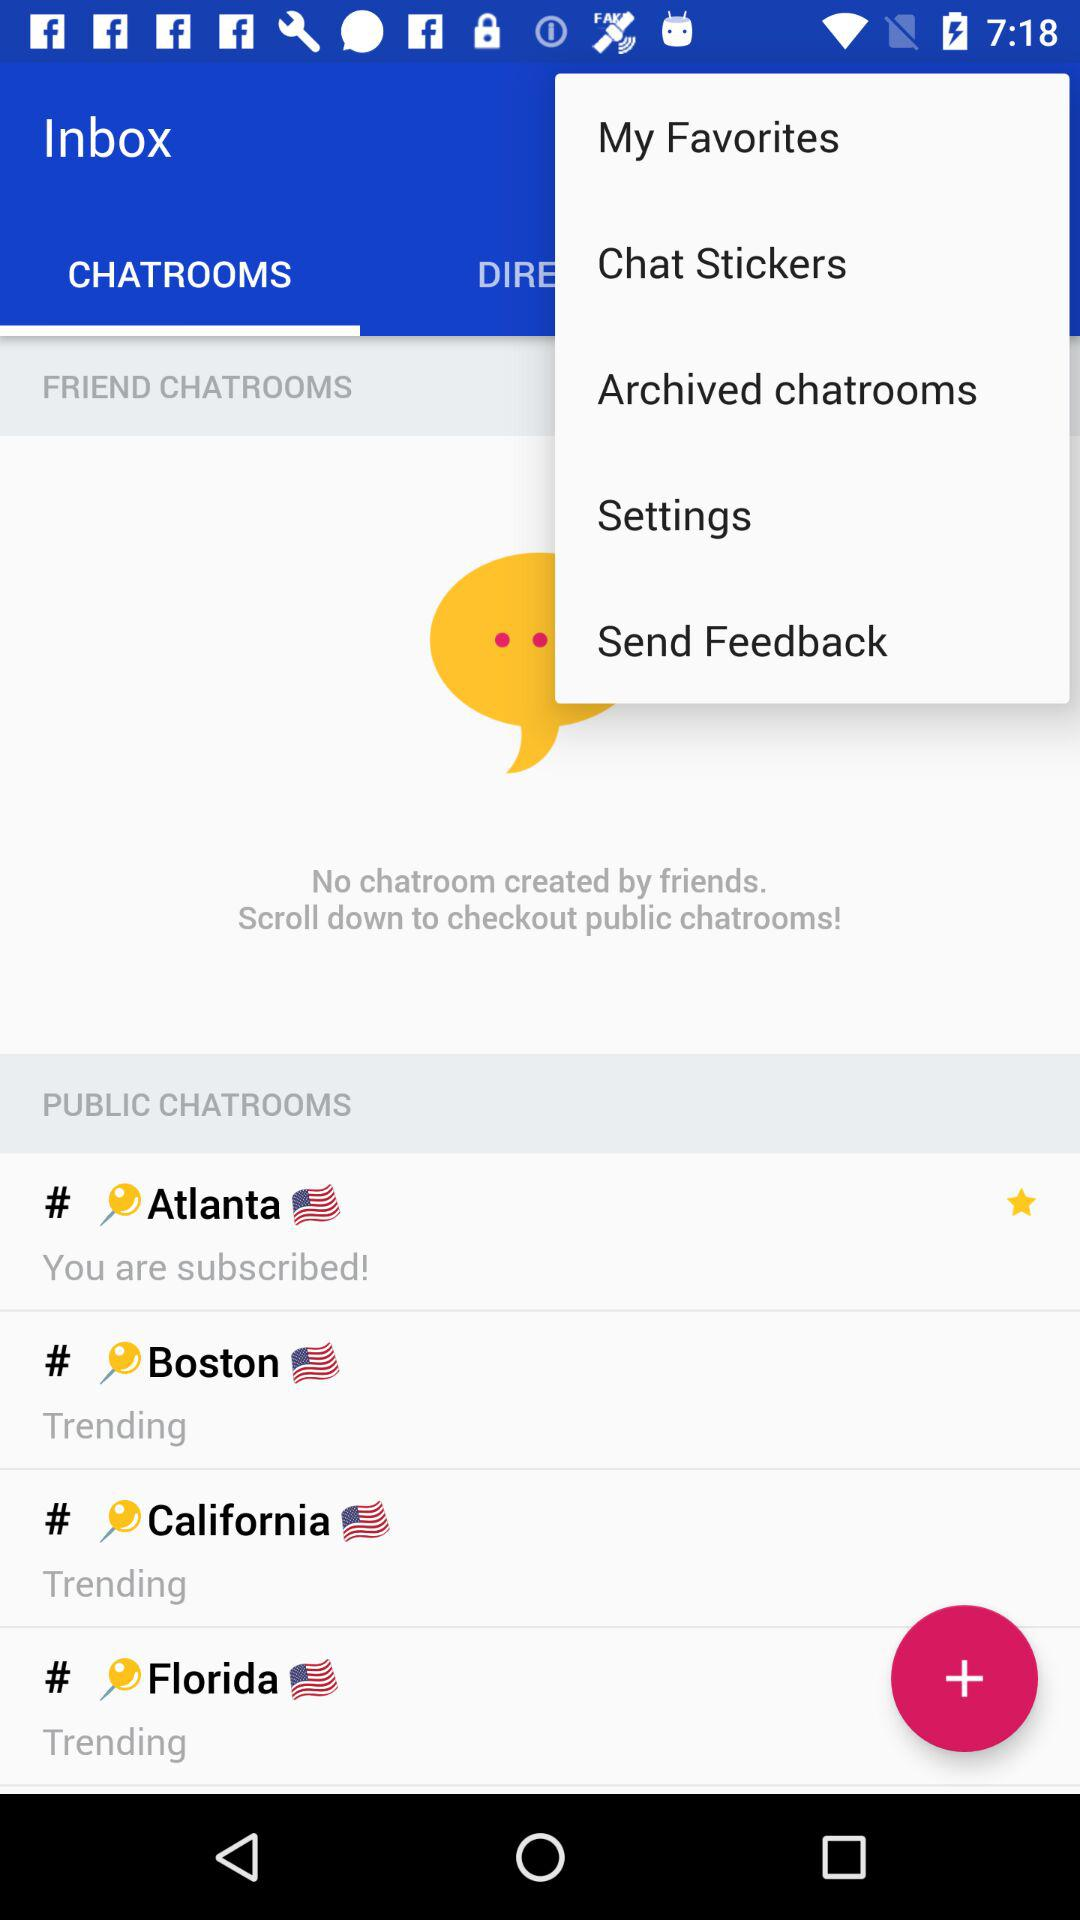How many chatrooms are in the public section?
Answer the question using a single word or phrase. 4 